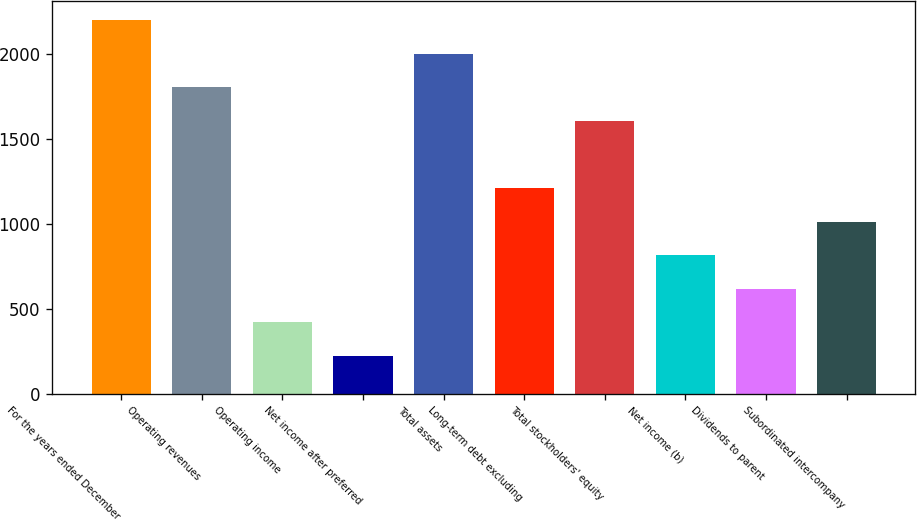Convert chart to OTSL. <chart><loc_0><loc_0><loc_500><loc_500><bar_chart><fcel>For the years ended December<fcel>Operating revenues<fcel>Operating income<fcel>Net income after preferred<fcel>Total assets<fcel>Long-term debt excluding<fcel>Total stockholders' equity<fcel>Net income (b)<fcel>Dividends to parent<fcel>Subordinated intercompany<nl><fcel>2203.1<fcel>1806.9<fcel>420.2<fcel>222.1<fcel>2005<fcel>1212.6<fcel>1608.8<fcel>816.4<fcel>618.3<fcel>1014.5<nl></chart> 